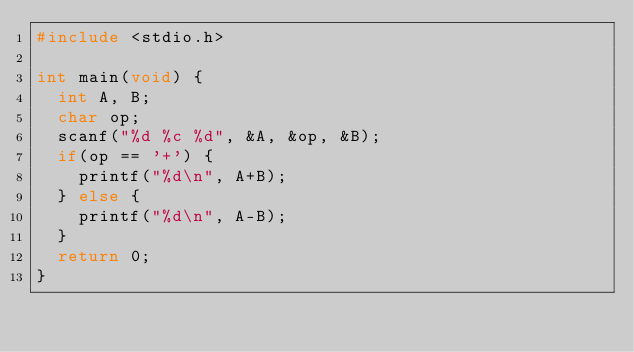<code> <loc_0><loc_0><loc_500><loc_500><_C_>#include <stdio.h>

int main(void) {
  int A, B;
  char op;
  scanf("%d %c %d", &A, &op, &B);
  if(op == '+') {
    printf("%d\n", A+B);
  } else {
    printf("%d\n", A-B);
  }
  return 0;
}
</code> 